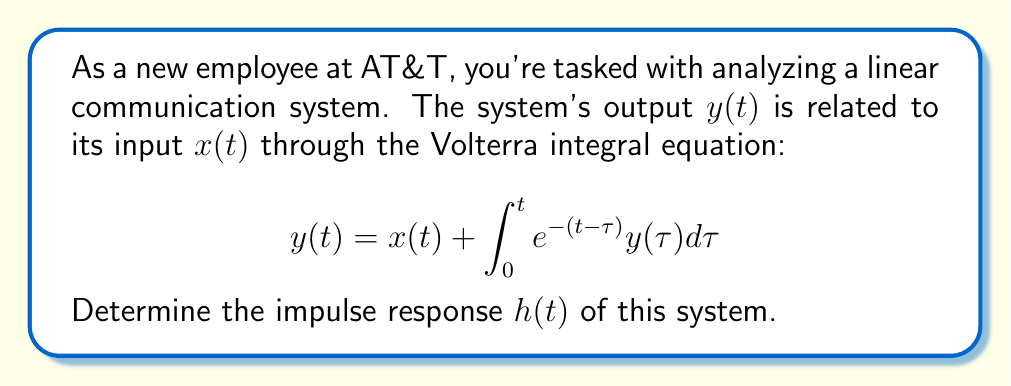Can you answer this question? To find the impulse response, we need to follow these steps:

1) The impulse response is defined as the output of the system when the input is a Dirac delta function, $\delta(t)$. So, we replace $x(t)$ with $\delta(t)$ in the given equation:

   $$h(t) = \delta(t) + \int_0^t e^{-(t-\tau)}h(\tau)d\tau$$

2) We can simplify this equation using the sifting property of the delta function:

   $$h(t) = 1 + \int_0^t e^{-(t-\tau)}h(\tau)d\tau$$

3) To solve this integral equation, we can differentiate both sides with respect to $t$:

   $$\frac{d}{dt}h(t) = \frac{d}{dt}\left(1 + \int_0^t e^{-(t-\tau)}h(\tau)d\tau\right)$$

4) Using the Leibniz rule for differentiation under the integral sign:

   $$\frac{d}{dt}h(t) = e^{-(t-t)}h(t) - \int_0^t \frac{d}{dt}e^{-(t-\tau)}h(\tau)d\tau$$

   $$\frac{d}{dt}h(t) = h(t) + \int_0^t e^{-(t-\tau)}h(\tau)d\tau$$

5) Substituting the original equation for the integral term:

   $$\frac{d}{dt}h(t) = h(t) + (h(t) - 1)$$

   $$\frac{d}{dt}h(t) = 2h(t) - 1$$

6) This is a first-order linear differential equation. We can solve it using standard methods:

   $$\frac{dh}{dt} + (-2)h = -1$$

   The general solution is:

   $$h(t) = Ce^{2t} + \frac{1}{2}$$

7) To find $C$, we use the initial condition $h(0) = 1$ (from step 2):

   $$1 = C + \frac{1}{2}$$
   $$C = \frac{1}{2}$$

8) Therefore, the impulse response is:

   $$h(t) = \frac{1}{2}e^{2t} + \frac{1}{2}$$
Answer: $h(t) = \frac{1}{2}e^{2t} + \frac{1}{2}$ 